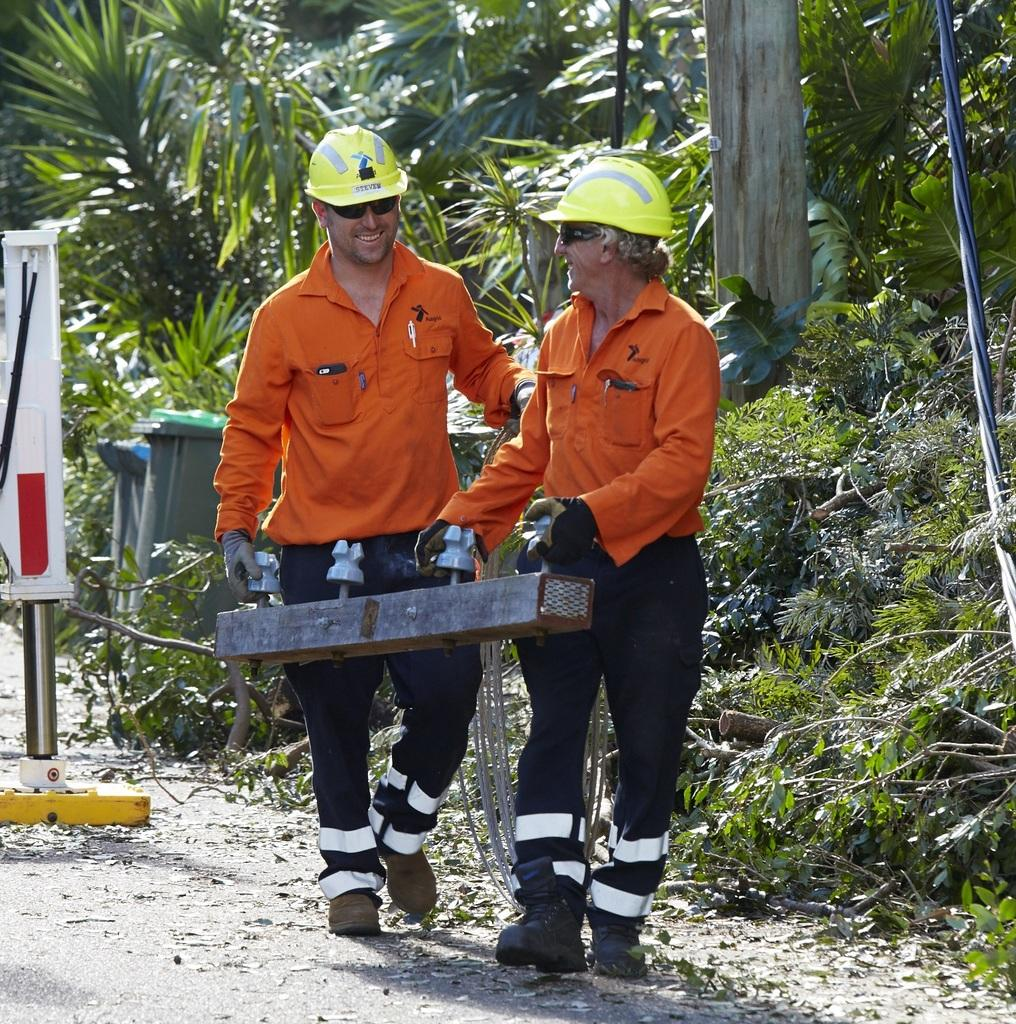How many people are in the image? There are two persons in the image. What are the two persons doing in the image? The two persons are holding an object. What can be seen in the background of the image? There are trees and dustbins in the background of the image. What is the main focus of the image? There is an object at the center of the image. What type of brush is the daughter using in the image? There is no daughter present in the image, and no brush can be seen. 